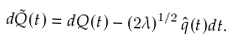Convert formula to latex. <formula><loc_0><loc_0><loc_500><loc_500>d { { \tilde { Q } } } ( t ) = d { Q } ( t ) - \left ( 2 \lambda \right ) ^ { 1 / 2 } \hat { q } ( t ) d t .</formula> 